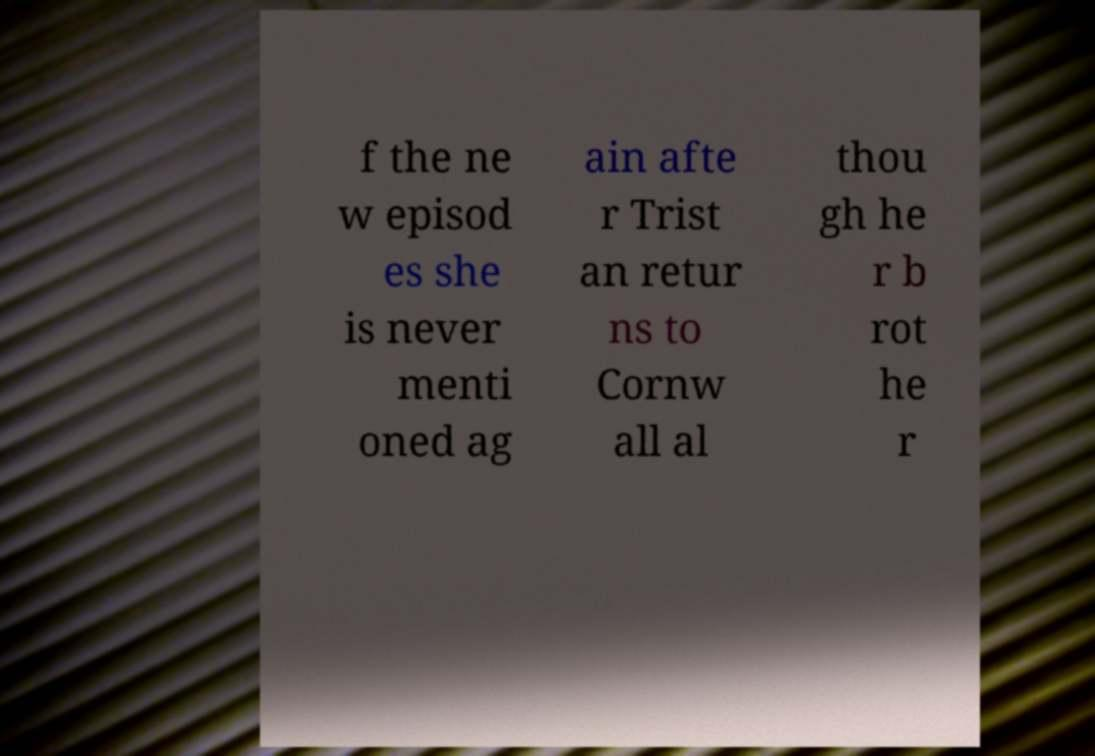For documentation purposes, I need the text within this image transcribed. Could you provide that? f the ne w episod es she is never menti oned ag ain afte r Trist an retur ns to Cornw all al thou gh he r b rot he r 